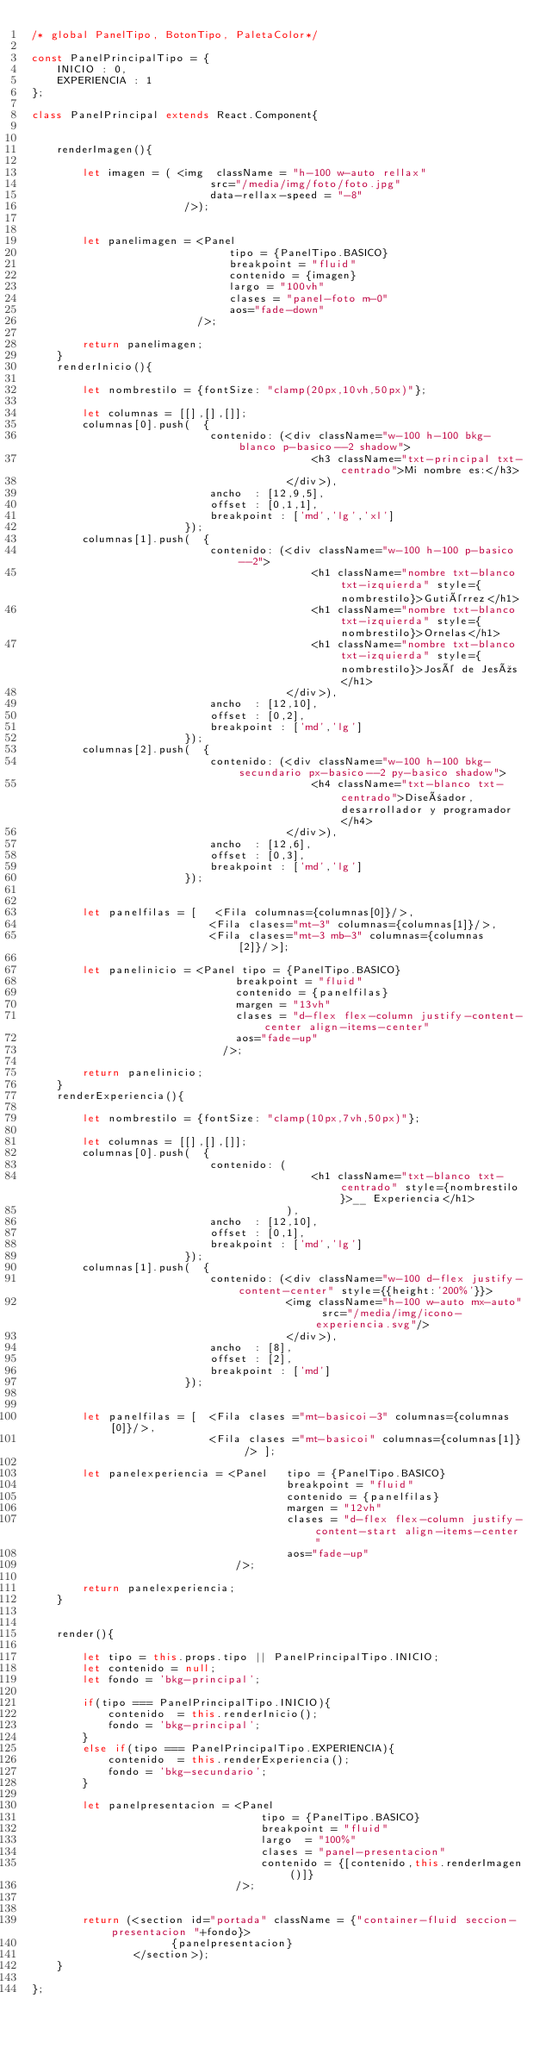<code> <loc_0><loc_0><loc_500><loc_500><_JavaScript_>/* global PanelTipo, BotonTipo, PaletaColor*/

const PanelPrincipalTipo = {
    INICIO : 0,
    EXPERIENCIA : 1
};

class PanelPrincipal extends React.Component{
    
            
    renderImagen(){
        
        let imagen = ( <img  className = "h-100 w-auto rellax" 
                            src="/media/img/foto/foto.jpg"
                            data-rellax-speed = "-8"
                        />);                   
                
                
        let panelimagen = <Panel    
                               tipo = {PanelTipo.BASICO}
                               breakpoint = "fluid"
                               contenido = {imagen}
                               largo = "100vh"
                               clases = "panel-foto m-0"    
                               aos="fade-down"
                          />;          
                          
        return panelimagen;
    }
    renderInicio(){
                
        let nombrestilo = {fontSize: "clamp(20px,10vh,50px)"};
                
        let columnas = [[],[],[]];        
        columnas[0].push(  {                        
                            contenido: (<div className="w-100 h-100 bkg-blanco p-basico--2 shadow">
                                            <h3 className="txt-principal txt-centrado">Mi nombre es:</h3>
                                        </div>),
                            ancho  : [12,9,5],
                            offset : [0,1,1],
                            breakpoint : ['md','lg','xl']
                        });
        columnas[1].push(  {                        
                            contenido: (<div className="w-100 h-100 p-basico--2">
                                            <h1 className="nombre txt-blanco txt-izquierda" style={nombrestilo}>Gutiérrez</h1>
                                            <h1 className="nombre txt-blanco txt-izquierda" style={nombrestilo}>Ornelas</h1>
                                            <h1 className="nombre txt-blanco txt-izquierda" style={nombrestilo}>José de Jesús</h1>
                                        </div>),
                            ancho  : [12,10],
                            offset : [0,2],              
                            breakpoint : ['md','lg']
                        });
        columnas[2].push(  {                        
                            contenido: (<div className="w-100 h-100 bkg-secundario px-basico--2 py-basico shadow">
                                            <h4 className="txt-blanco txt-centrado">Diseñador,desarrollador y programador</h4>
                                        </div>),
                            ancho  : [12,6],
                            offset : [0,3],              
                            breakpoint : ['md','lg']                            
                        });
                        
               
        let panelfilas = [   <Fila columnas={columnas[0]}/>,
                            <Fila clases="mt-3" columnas={columnas[1]}/>,
                            <Fila clases="mt-3 mb-3" columnas={columnas[2]}/>];
                
        let panelinicio = <Panel tipo = {PanelTipo.BASICO} 
                                breakpoint = "fluid"                                
                                contenido = {panelfilas}
                                margen = "13vh"
                                clases = "d-flex flex-column justify-content-center align-items-center"
                                aos="fade-up"
                              />;
                              
        return panelinicio;
    }
    renderExperiencia(){
                
        let nombrestilo = {fontSize: "clamp(10px,7vh,50px)"};
                
        let columnas = [[],[],[]];   
        columnas[0].push(  {                        
                            contenido: (
                                            <h1 className="txt-blanco txt-centrado" style={nombrestilo}>__ Experiencia</h1>
                                        ),
                            ancho  : [12,10],
                            offset : [0,1],              
                            breakpoint : ['md','lg']
                        });
        columnas[1].push(  {                        
                            contenido: (<div className="w-100 d-flex justify-content-center" style={{height:'200%'}}>
                                        <img className="h-100 w-auto mx-auto" src="/media/img/icono-experiencia.svg"/>
                                        </div>),
                            ancho  : [8],
                            offset : [2],
                            breakpoint : ['md']
                        });
        
                                      
        let panelfilas = [  <Fila clases ="mt-basicoi-3" columnas={columnas[0]}/>,
                            <Fila clases ="mt-basicoi" columnas={columnas[1]} /> ];
                
        let panelexperiencia = <Panel   tipo = {PanelTipo.BASICO} 
                                        breakpoint = "fluid"                                
                                        contenido = {panelfilas}
                                        margen = "12vh"
                                        clases = "d-flex flex-column justify-content-start align-items-center"
                                        aos="fade-up"
                                />;
                              
        return panelexperiencia;
    }
    
    
    render(){
            
        let tipo = this.props.tipo || PanelPrincipalTipo.INICIO;
        let contenido = null;
        let fondo = 'bkg-principal';
        
        if(tipo === PanelPrincipalTipo.INICIO){
            contenido  = this.renderInicio();
            fondo = 'bkg-principal';
        }
        else if(tipo === PanelPrincipalTipo.EXPERIENCIA){
            contenido  = this.renderExperiencia();
            fondo = 'bkg-secundario';
        }
        
        let panelpresentacion = <Panel    
                                    tipo = {PanelTipo.BASICO}           
                                    breakpoint = "fluid"   
                                    largo  = "100%"
                                    clases = "panel-presentacion"    
                                    contenido = {[contenido,this.renderImagen()]}
                                />;                  
        
        
        return (<section id="portada" className = {"container-fluid seccion-presentacion "+fondo}>
                      {panelpresentacion}                             
                </section>);
    }
       
};
</code> 